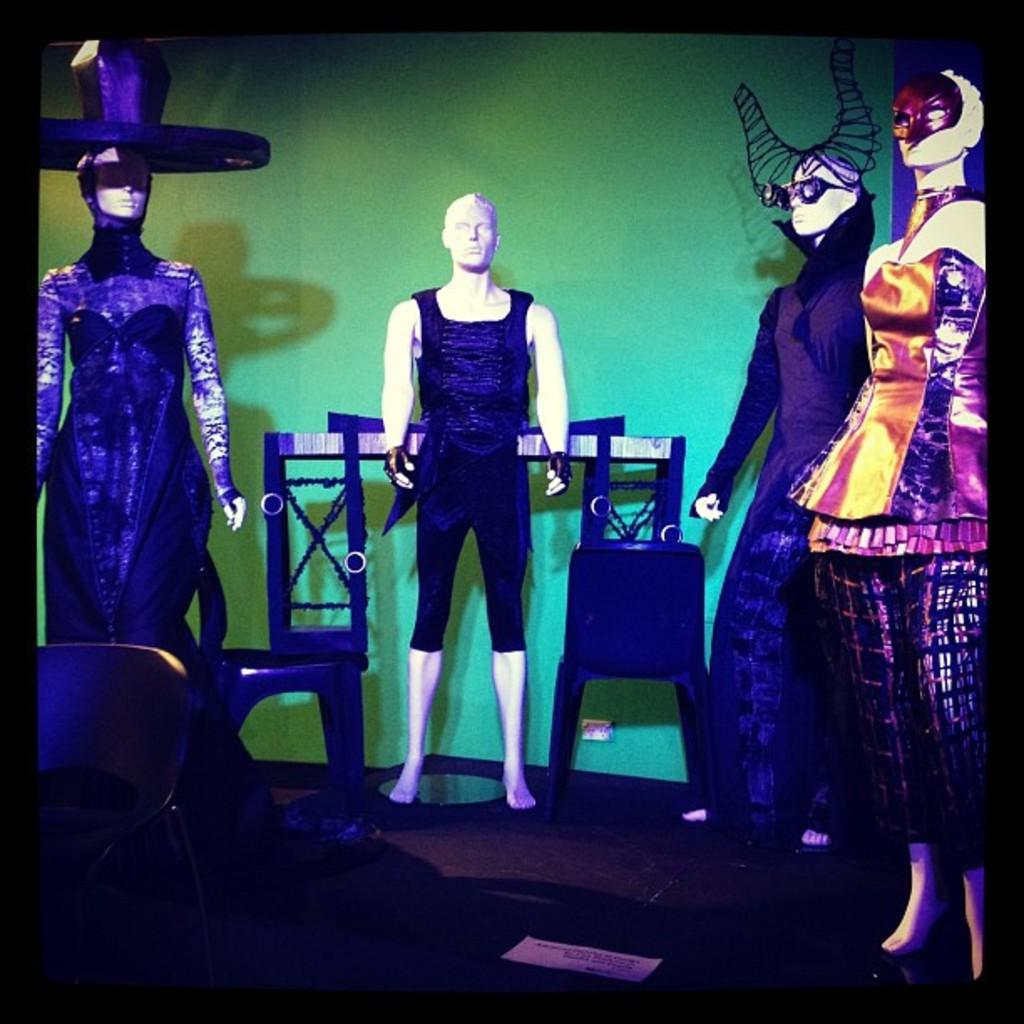What type of objects are in the image? There are mannequins in the image. What are the mannequins wearing? The mannequins are wearing different color dresses. What can be seen behind the mannequins? There is a wall in the image. What color is the wall? The wall is green in color. What type of salt is being used to mark the territory in the image? There is no salt or territory being marked in the image. 